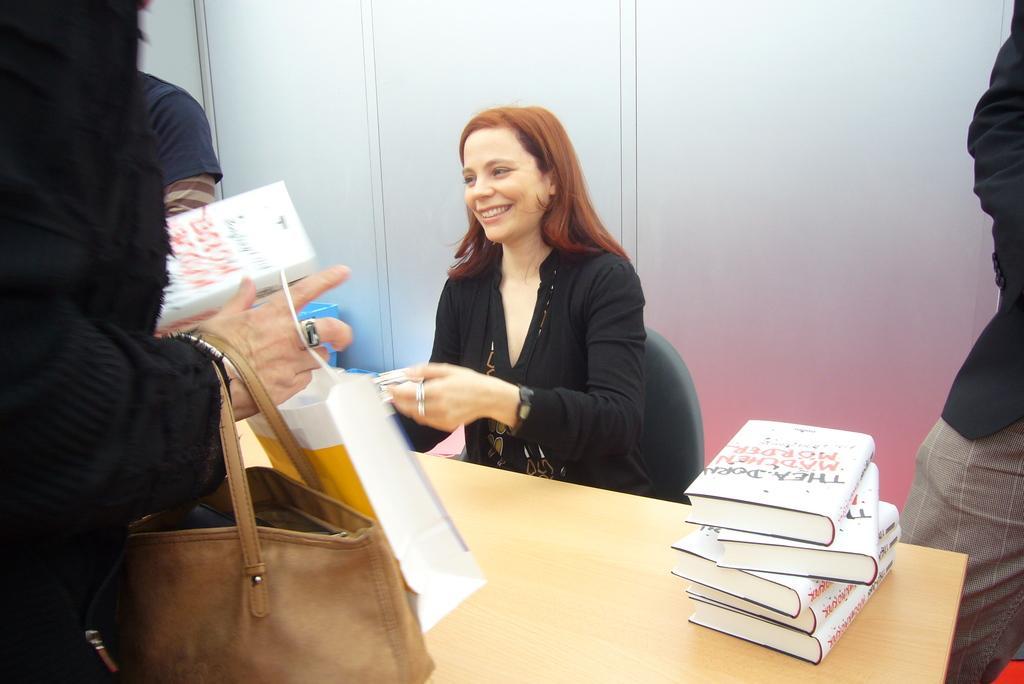In one or two sentences, can you explain what this image depicts? This is the picture of four people among them one lady is sitting and the other three are standing around the table on which there are some books. 